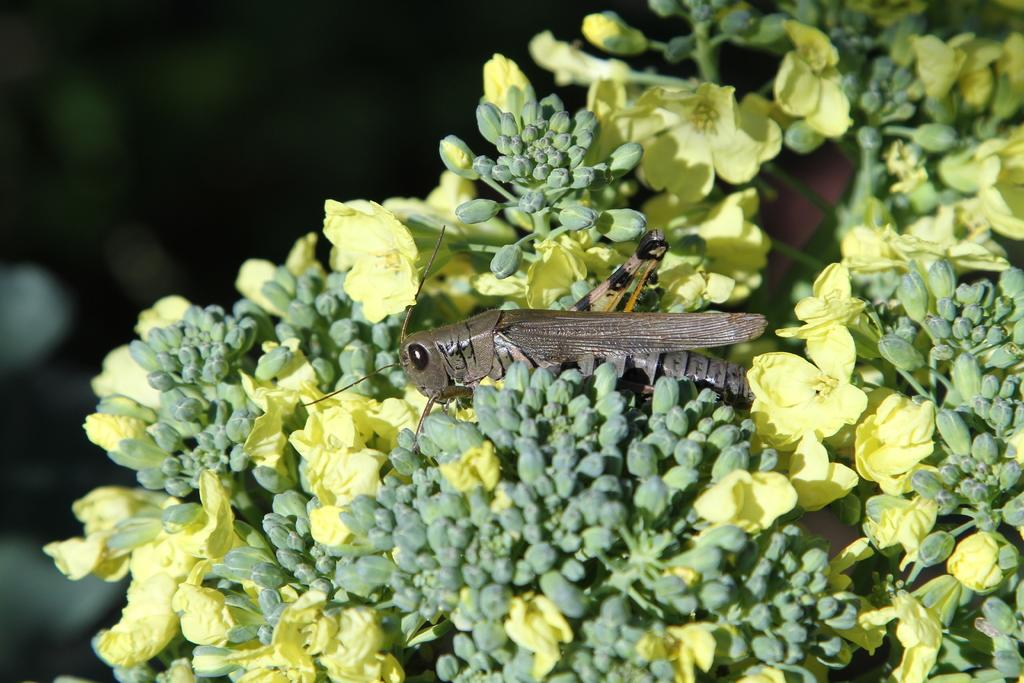What is the main subject of the image? The main subject of the image is a grasshopper. Where is the grasshopper located in the image? The grasshopper is on the flowers. What other elements can be seen in the image besides the grasshopper? There are flowers in the image. How would you describe the background of the image? The background of the image has a dark view. What type of veil can be seen covering the flowers in the image? There is no veil present in the image; the flowers are not covered. What drink is the grasshopper holding in its hands in the image? The grasshopper does not have hands, and there is no drink present in the image. 